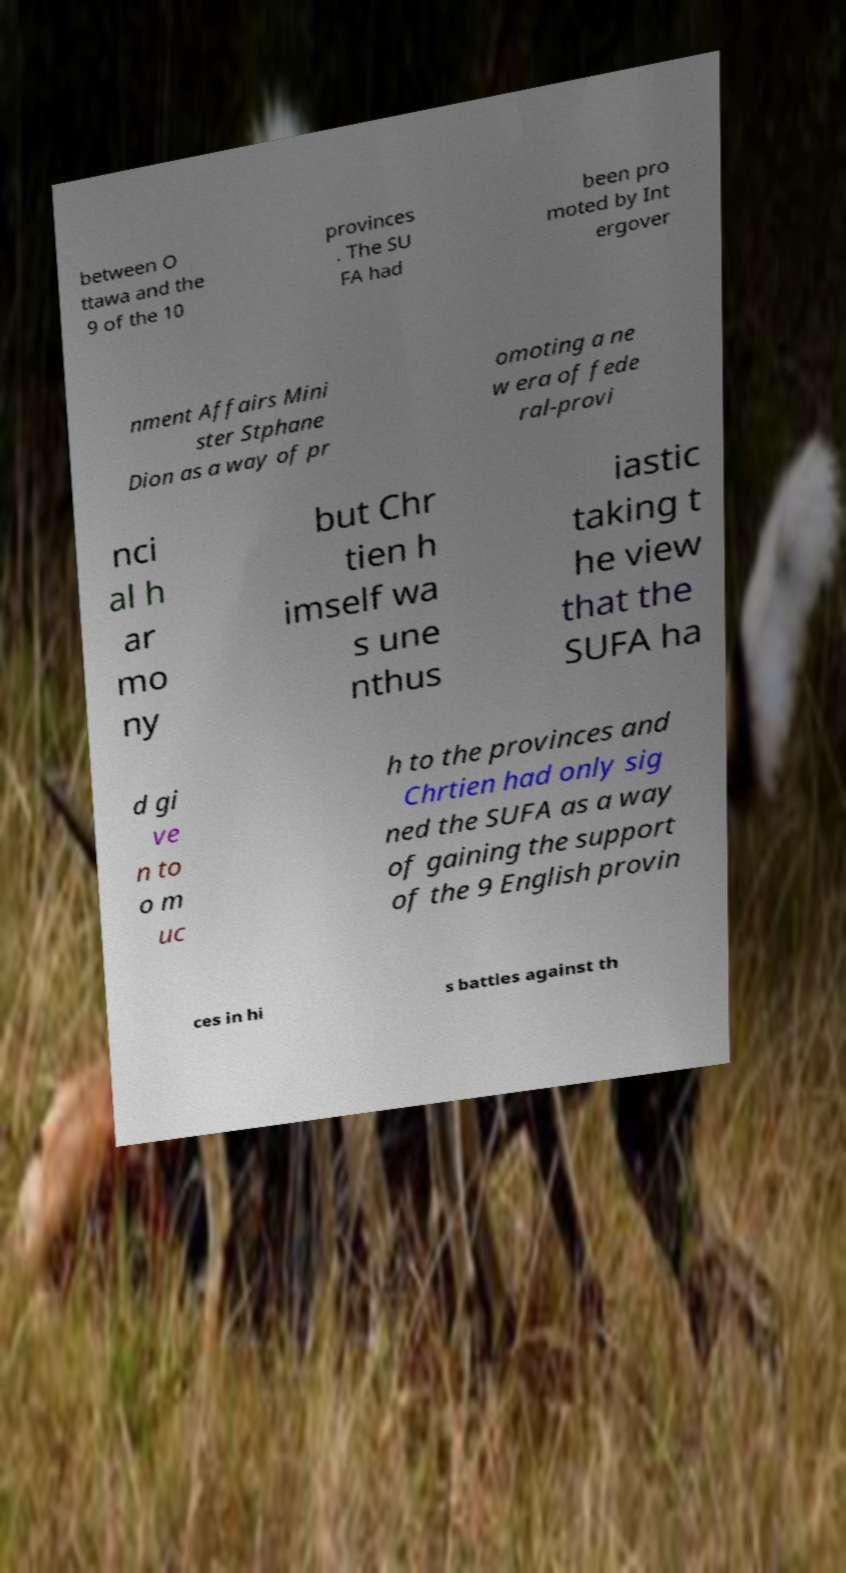Please read and relay the text visible in this image. What does it say? between O ttawa and the 9 of the 10 provinces . The SU FA had been pro moted by Int ergover nment Affairs Mini ster Stphane Dion as a way of pr omoting a ne w era of fede ral-provi nci al h ar mo ny but Chr tien h imself wa s une nthus iastic taking t he view that the SUFA ha d gi ve n to o m uc h to the provinces and Chrtien had only sig ned the SUFA as a way of gaining the support of the 9 English provin ces in hi s battles against th 